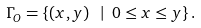<formula> <loc_0><loc_0><loc_500><loc_500>\Gamma _ { O } = \left \{ \left ( x , y \right ) \text { } | \text { } 0 \leq x \leq y \right \} .</formula> 